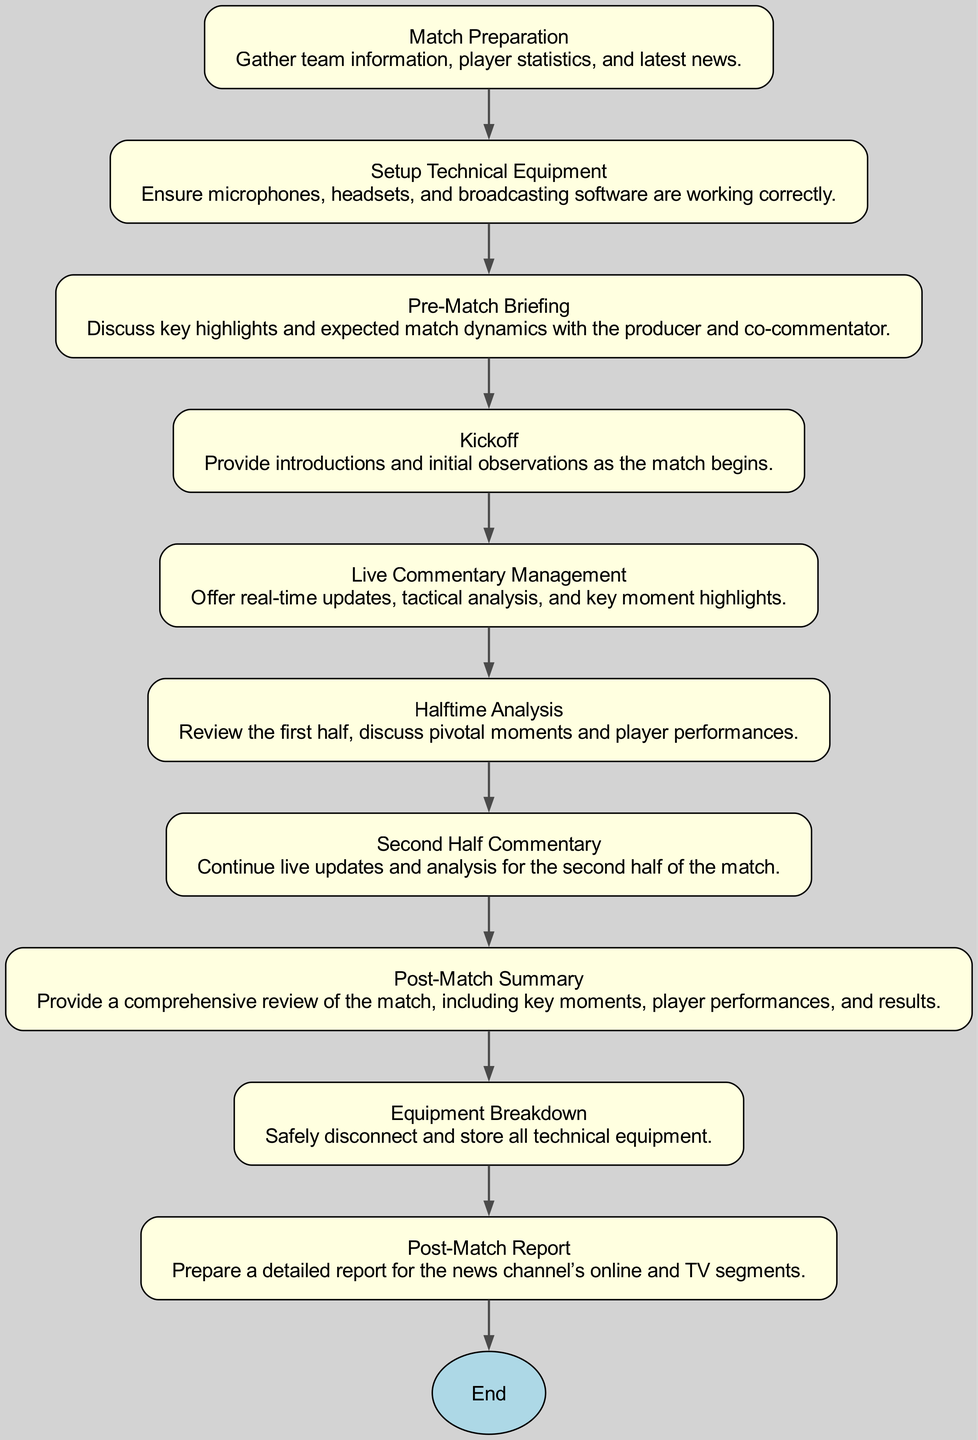What is the first step in the process for managing live match commentary? The diagram indicates that the first step to start the process is "Match Preparation," where team information, player statistics, and latest news are gathered.
Answer: Match Preparation How many nodes are present in the diagram? By counting all the unique steps present in the diagram, there are a total of 10 nodes listed, including the "End" node.
Answer: 10 What is the last step before the end of the process? According to the diagram, the last step before reaching the "End" node is "Post-Match Report," which involves preparing a detailed report for the news segments.
Answer: Post-Match Report What is the purpose of the "Halftime Analysis" step? The diagram shows that "Halftime Analysis" involves reviewing the first half, discussing pivotal moments, and assessing player performances, making it crucial for match evaluation.
Answer: Review first half Which steps directly lead to "Live Commentary Management"? The diagram shows a direct flow from "Kickoff" to "Live Commentary Management," indicating that these steps are sequentially connected in the process.
Answer: Kickoff How does the "Post-Match Summary" relate to "Halftime Analysis"? In the process flow, "Halftime Analysis" occurs before "Second Half Commentary," and directly precedes "Post-Match Summary," indicating that both steps contribute to the overall match analysis.
Answer: Sequential relationship What technical aspects are checked in "Setup Technical Equipment"? The "Setup Technical Equipment" step focuses on ensuring that microphones, headsets, and broadcasting software are working correctly, vital for delivering quality commentary.
Answer: Technical equipment checks What happens after "Second Half Commentary"? The next step following "Second Half Commentary" is "Post-Match Summary," indicating the continuous flow of tasks to provide comprehensive insights after the match.
Answer: Post-Match Summary 